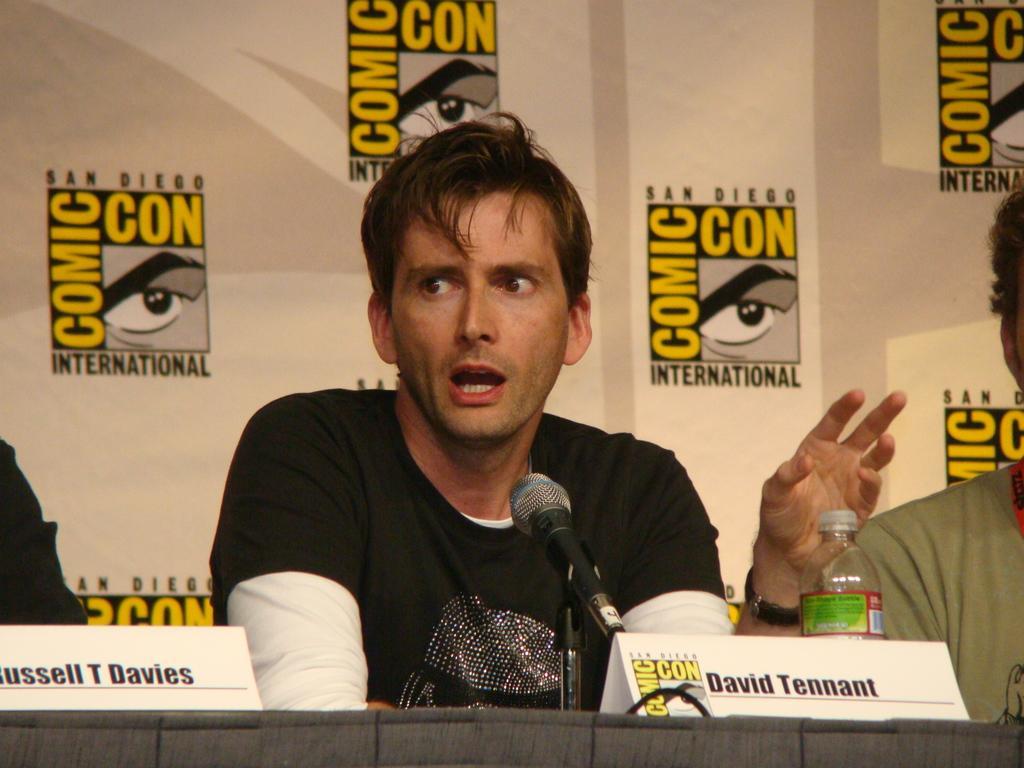Describe this image in one or two sentences. A man is sitting on the chair and talking on the microphone,in-front of him there is a water bottle behind him there is a banner,there are 2 persons beside him. 